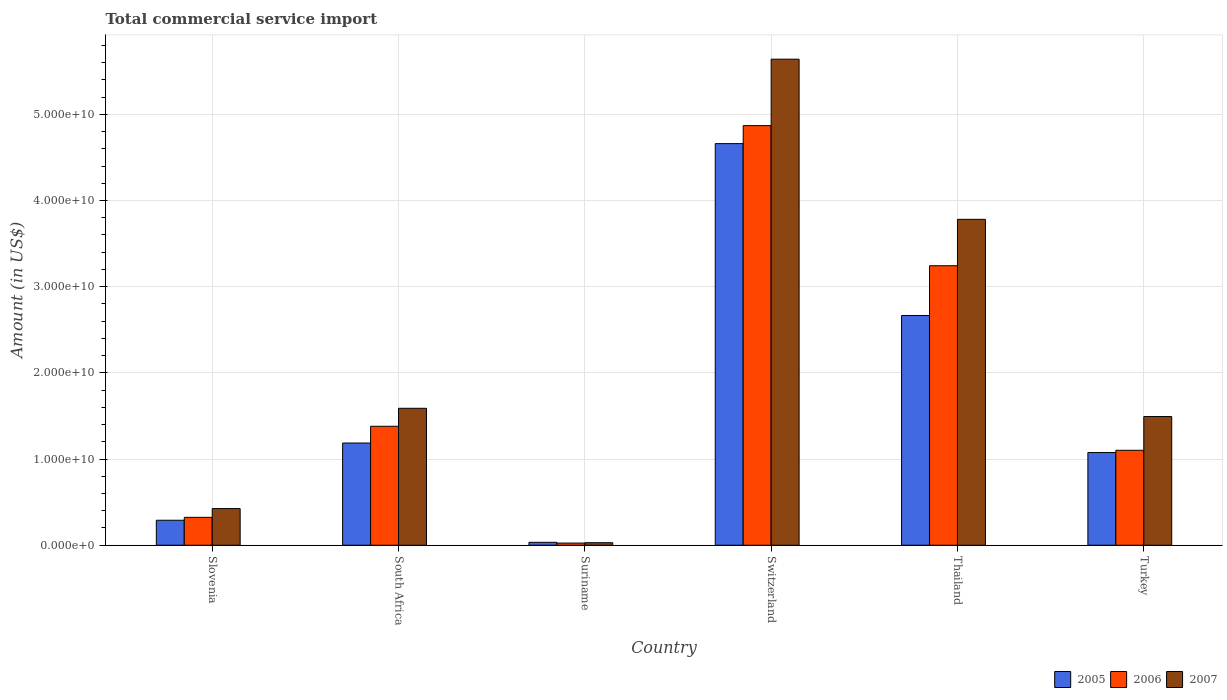How many different coloured bars are there?
Keep it short and to the point. 3. Are the number of bars per tick equal to the number of legend labels?
Ensure brevity in your answer.  Yes. Are the number of bars on each tick of the X-axis equal?
Provide a short and direct response. Yes. What is the total commercial service import in 2005 in Suriname?
Ensure brevity in your answer.  3.39e+08. Across all countries, what is the maximum total commercial service import in 2005?
Give a very brief answer. 4.66e+1. Across all countries, what is the minimum total commercial service import in 2006?
Provide a short and direct response. 2.51e+08. In which country was the total commercial service import in 2005 maximum?
Give a very brief answer. Switzerland. In which country was the total commercial service import in 2006 minimum?
Your response must be concise. Suriname. What is the total total commercial service import in 2005 in the graph?
Offer a terse response. 9.91e+1. What is the difference between the total commercial service import in 2007 in Suriname and that in Turkey?
Offer a terse response. -1.46e+1. What is the difference between the total commercial service import in 2006 in Slovenia and the total commercial service import in 2007 in Suriname?
Ensure brevity in your answer.  2.94e+09. What is the average total commercial service import in 2006 per country?
Keep it short and to the point. 1.82e+1. What is the difference between the total commercial service import of/in 2006 and total commercial service import of/in 2005 in Turkey?
Provide a succinct answer. 2.61e+08. In how many countries, is the total commercial service import in 2006 greater than 6000000000 US$?
Keep it short and to the point. 4. What is the ratio of the total commercial service import in 2005 in Slovenia to that in Switzerland?
Your answer should be very brief. 0.06. Is the total commercial service import in 2007 in Switzerland less than that in Thailand?
Ensure brevity in your answer.  No. What is the difference between the highest and the second highest total commercial service import in 2006?
Offer a very short reply. -1.63e+1. What is the difference between the highest and the lowest total commercial service import in 2005?
Offer a very short reply. 4.63e+1. In how many countries, is the total commercial service import in 2006 greater than the average total commercial service import in 2006 taken over all countries?
Keep it short and to the point. 2. Is the sum of the total commercial service import in 2005 in South Africa and Thailand greater than the maximum total commercial service import in 2006 across all countries?
Your answer should be very brief. No. Is it the case that in every country, the sum of the total commercial service import in 2007 and total commercial service import in 2006 is greater than the total commercial service import in 2005?
Make the answer very short. Yes. What is the difference between two consecutive major ticks on the Y-axis?
Keep it short and to the point. 1.00e+1. Are the values on the major ticks of Y-axis written in scientific E-notation?
Provide a short and direct response. Yes. Does the graph contain any zero values?
Your answer should be compact. No. Does the graph contain grids?
Offer a terse response. Yes. Where does the legend appear in the graph?
Provide a short and direct response. Bottom right. How are the legend labels stacked?
Your answer should be compact. Horizontal. What is the title of the graph?
Give a very brief answer. Total commercial service import. What is the label or title of the X-axis?
Your answer should be compact. Country. What is the Amount (in US$) in 2005 in Slovenia?
Your response must be concise. 2.90e+09. What is the Amount (in US$) of 2006 in Slovenia?
Provide a succinct answer. 3.24e+09. What is the Amount (in US$) in 2007 in Slovenia?
Your response must be concise. 4.25e+09. What is the Amount (in US$) of 2005 in South Africa?
Provide a succinct answer. 1.19e+1. What is the Amount (in US$) in 2006 in South Africa?
Give a very brief answer. 1.38e+1. What is the Amount (in US$) in 2007 in South Africa?
Provide a short and direct response. 1.59e+1. What is the Amount (in US$) in 2005 in Suriname?
Ensure brevity in your answer.  3.39e+08. What is the Amount (in US$) of 2006 in Suriname?
Give a very brief answer. 2.51e+08. What is the Amount (in US$) of 2007 in Suriname?
Keep it short and to the point. 2.93e+08. What is the Amount (in US$) in 2005 in Switzerland?
Give a very brief answer. 4.66e+1. What is the Amount (in US$) in 2006 in Switzerland?
Provide a succinct answer. 4.87e+1. What is the Amount (in US$) in 2007 in Switzerland?
Keep it short and to the point. 5.64e+1. What is the Amount (in US$) of 2005 in Thailand?
Your answer should be very brief. 2.67e+1. What is the Amount (in US$) in 2006 in Thailand?
Your answer should be compact. 3.24e+1. What is the Amount (in US$) in 2007 in Thailand?
Your response must be concise. 3.78e+1. What is the Amount (in US$) in 2005 in Turkey?
Your answer should be compact. 1.08e+1. What is the Amount (in US$) in 2006 in Turkey?
Keep it short and to the point. 1.10e+1. What is the Amount (in US$) in 2007 in Turkey?
Offer a terse response. 1.49e+1. Across all countries, what is the maximum Amount (in US$) of 2005?
Your answer should be very brief. 4.66e+1. Across all countries, what is the maximum Amount (in US$) of 2006?
Keep it short and to the point. 4.87e+1. Across all countries, what is the maximum Amount (in US$) of 2007?
Provide a short and direct response. 5.64e+1. Across all countries, what is the minimum Amount (in US$) in 2005?
Make the answer very short. 3.39e+08. Across all countries, what is the minimum Amount (in US$) in 2006?
Provide a succinct answer. 2.51e+08. Across all countries, what is the minimum Amount (in US$) of 2007?
Your response must be concise. 2.93e+08. What is the total Amount (in US$) in 2005 in the graph?
Your answer should be compact. 9.91e+1. What is the total Amount (in US$) of 2006 in the graph?
Make the answer very short. 1.09e+11. What is the total Amount (in US$) in 2007 in the graph?
Your answer should be very brief. 1.30e+11. What is the difference between the Amount (in US$) in 2005 in Slovenia and that in South Africa?
Offer a terse response. -8.96e+09. What is the difference between the Amount (in US$) in 2006 in Slovenia and that in South Africa?
Keep it short and to the point. -1.06e+1. What is the difference between the Amount (in US$) of 2007 in Slovenia and that in South Africa?
Your answer should be compact. -1.16e+1. What is the difference between the Amount (in US$) in 2005 in Slovenia and that in Suriname?
Ensure brevity in your answer.  2.56e+09. What is the difference between the Amount (in US$) of 2006 in Slovenia and that in Suriname?
Ensure brevity in your answer.  2.98e+09. What is the difference between the Amount (in US$) of 2007 in Slovenia and that in Suriname?
Provide a succinct answer. 3.96e+09. What is the difference between the Amount (in US$) in 2005 in Slovenia and that in Switzerland?
Provide a succinct answer. -4.37e+1. What is the difference between the Amount (in US$) of 2006 in Slovenia and that in Switzerland?
Ensure brevity in your answer.  -4.55e+1. What is the difference between the Amount (in US$) in 2007 in Slovenia and that in Switzerland?
Provide a succinct answer. -5.21e+1. What is the difference between the Amount (in US$) in 2005 in Slovenia and that in Thailand?
Your answer should be compact. -2.38e+1. What is the difference between the Amount (in US$) of 2006 in Slovenia and that in Thailand?
Ensure brevity in your answer.  -2.92e+1. What is the difference between the Amount (in US$) in 2007 in Slovenia and that in Thailand?
Your answer should be very brief. -3.36e+1. What is the difference between the Amount (in US$) of 2005 in Slovenia and that in Turkey?
Your answer should be compact. -7.86e+09. What is the difference between the Amount (in US$) in 2006 in Slovenia and that in Turkey?
Your answer should be compact. -7.78e+09. What is the difference between the Amount (in US$) of 2007 in Slovenia and that in Turkey?
Your answer should be compact. -1.07e+1. What is the difference between the Amount (in US$) of 2005 in South Africa and that in Suriname?
Give a very brief answer. 1.15e+1. What is the difference between the Amount (in US$) in 2006 in South Africa and that in Suriname?
Give a very brief answer. 1.36e+1. What is the difference between the Amount (in US$) in 2007 in South Africa and that in Suriname?
Make the answer very short. 1.56e+1. What is the difference between the Amount (in US$) of 2005 in South Africa and that in Switzerland?
Your answer should be very brief. -3.47e+1. What is the difference between the Amount (in US$) in 2006 in South Africa and that in Switzerland?
Ensure brevity in your answer.  -3.49e+1. What is the difference between the Amount (in US$) of 2007 in South Africa and that in Switzerland?
Offer a terse response. -4.05e+1. What is the difference between the Amount (in US$) in 2005 in South Africa and that in Thailand?
Offer a terse response. -1.48e+1. What is the difference between the Amount (in US$) in 2006 in South Africa and that in Thailand?
Your answer should be very brief. -1.86e+1. What is the difference between the Amount (in US$) in 2007 in South Africa and that in Thailand?
Keep it short and to the point. -2.19e+1. What is the difference between the Amount (in US$) of 2005 in South Africa and that in Turkey?
Ensure brevity in your answer.  1.10e+09. What is the difference between the Amount (in US$) of 2006 in South Africa and that in Turkey?
Provide a succinct answer. 2.79e+09. What is the difference between the Amount (in US$) of 2007 in South Africa and that in Turkey?
Provide a succinct answer. 9.57e+08. What is the difference between the Amount (in US$) in 2005 in Suriname and that in Switzerland?
Provide a succinct answer. -4.63e+1. What is the difference between the Amount (in US$) in 2006 in Suriname and that in Switzerland?
Provide a succinct answer. -4.84e+1. What is the difference between the Amount (in US$) in 2007 in Suriname and that in Switzerland?
Make the answer very short. -5.61e+1. What is the difference between the Amount (in US$) in 2005 in Suriname and that in Thailand?
Provide a succinct answer. -2.63e+1. What is the difference between the Amount (in US$) in 2006 in Suriname and that in Thailand?
Keep it short and to the point. -3.22e+1. What is the difference between the Amount (in US$) of 2007 in Suriname and that in Thailand?
Provide a succinct answer. -3.75e+1. What is the difference between the Amount (in US$) in 2005 in Suriname and that in Turkey?
Your response must be concise. -1.04e+1. What is the difference between the Amount (in US$) of 2006 in Suriname and that in Turkey?
Provide a short and direct response. -1.08e+1. What is the difference between the Amount (in US$) in 2007 in Suriname and that in Turkey?
Ensure brevity in your answer.  -1.46e+1. What is the difference between the Amount (in US$) in 2005 in Switzerland and that in Thailand?
Your answer should be compact. 1.99e+1. What is the difference between the Amount (in US$) of 2006 in Switzerland and that in Thailand?
Offer a very short reply. 1.63e+1. What is the difference between the Amount (in US$) of 2007 in Switzerland and that in Thailand?
Your answer should be very brief. 1.86e+1. What is the difference between the Amount (in US$) of 2005 in Switzerland and that in Turkey?
Ensure brevity in your answer.  3.58e+1. What is the difference between the Amount (in US$) in 2006 in Switzerland and that in Turkey?
Your answer should be very brief. 3.77e+1. What is the difference between the Amount (in US$) in 2007 in Switzerland and that in Turkey?
Offer a very short reply. 4.15e+1. What is the difference between the Amount (in US$) of 2005 in Thailand and that in Turkey?
Provide a short and direct response. 1.59e+1. What is the difference between the Amount (in US$) in 2006 in Thailand and that in Turkey?
Provide a succinct answer. 2.14e+1. What is the difference between the Amount (in US$) in 2007 in Thailand and that in Turkey?
Your response must be concise. 2.29e+1. What is the difference between the Amount (in US$) of 2005 in Slovenia and the Amount (in US$) of 2006 in South Africa?
Your response must be concise. -1.09e+1. What is the difference between the Amount (in US$) in 2005 in Slovenia and the Amount (in US$) in 2007 in South Africa?
Provide a short and direct response. -1.30e+1. What is the difference between the Amount (in US$) of 2006 in Slovenia and the Amount (in US$) of 2007 in South Africa?
Offer a terse response. -1.27e+1. What is the difference between the Amount (in US$) in 2005 in Slovenia and the Amount (in US$) in 2006 in Suriname?
Make the answer very short. 2.65e+09. What is the difference between the Amount (in US$) of 2005 in Slovenia and the Amount (in US$) of 2007 in Suriname?
Your response must be concise. 2.61e+09. What is the difference between the Amount (in US$) of 2006 in Slovenia and the Amount (in US$) of 2007 in Suriname?
Your answer should be very brief. 2.94e+09. What is the difference between the Amount (in US$) in 2005 in Slovenia and the Amount (in US$) in 2006 in Switzerland?
Your answer should be very brief. -4.58e+1. What is the difference between the Amount (in US$) of 2005 in Slovenia and the Amount (in US$) of 2007 in Switzerland?
Offer a very short reply. -5.35e+1. What is the difference between the Amount (in US$) of 2006 in Slovenia and the Amount (in US$) of 2007 in Switzerland?
Keep it short and to the point. -5.32e+1. What is the difference between the Amount (in US$) of 2005 in Slovenia and the Amount (in US$) of 2006 in Thailand?
Offer a terse response. -2.95e+1. What is the difference between the Amount (in US$) in 2005 in Slovenia and the Amount (in US$) in 2007 in Thailand?
Offer a very short reply. -3.49e+1. What is the difference between the Amount (in US$) in 2006 in Slovenia and the Amount (in US$) in 2007 in Thailand?
Provide a succinct answer. -3.46e+1. What is the difference between the Amount (in US$) in 2005 in Slovenia and the Amount (in US$) in 2006 in Turkey?
Provide a succinct answer. -8.12e+09. What is the difference between the Amount (in US$) of 2005 in Slovenia and the Amount (in US$) of 2007 in Turkey?
Your answer should be compact. -1.20e+1. What is the difference between the Amount (in US$) in 2006 in Slovenia and the Amount (in US$) in 2007 in Turkey?
Make the answer very short. -1.17e+1. What is the difference between the Amount (in US$) of 2005 in South Africa and the Amount (in US$) of 2006 in Suriname?
Provide a succinct answer. 1.16e+1. What is the difference between the Amount (in US$) in 2005 in South Africa and the Amount (in US$) in 2007 in Suriname?
Offer a terse response. 1.16e+1. What is the difference between the Amount (in US$) of 2006 in South Africa and the Amount (in US$) of 2007 in Suriname?
Offer a very short reply. 1.35e+1. What is the difference between the Amount (in US$) of 2005 in South Africa and the Amount (in US$) of 2006 in Switzerland?
Give a very brief answer. -3.68e+1. What is the difference between the Amount (in US$) of 2005 in South Africa and the Amount (in US$) of 2007 in Switzerland?
Your response must be concise. -4.45e+1. What is the difference between the Amount (in US$) of 2006 in South Africa and the Amount (in US$) of 2007 in Switzerland?
Offer a very short reply. -4.26e+1. What is the difference between the Amount (in US$) of 2005 in South Africa and the Amount (in US$) of 2006 in Thailand?
Your answer should be compact. -2.06e+1. What is the difference between the Amount (in US$) in 2005 in South Africa and the Amount (in US$) in 2007 in Thailand?
Your answer should be very brief. -2.60e+1. What is the difference between the Amount (in US$) of 2006 in South Africa and the Amount (in US$) of 2007 in Thailand?
Provide a succinct answer. -2.40e+1. What is the difference between the Amount (in US$) of 2005 in South Africa and the Amount (in US$) of 2006 in Turkey?
Make the answer very short. 8.42e+08. What is the difference between the Amount (in US$) of 2005 in South Africa and the Amount (in US$) of 2007 in Turkey?
Provide a short and direct response. -3.07e+09. What is the difference between the Amount (in US$) of 2006 in South Africa and the Amount (in US$) of 2007 in Turkey?
Give a very brief answer. -1.13e+09. What is the difference between the Amount (in US$) of 2005 in Suriname and the Amount (in US$) of 2006 in Switzerland?
Offer a terse response. -4.83e+1. What is the difference between the Amount (in US$) of 2005 in Suriname and the Amount (in US$) of 2007 in Switzerland?
Provide a short and direct response. -5.61e+1. What is the difference between the Amount (in US$) of 2006 in Suriname and the Amount (in US$) of 2007 in Switzerland?
Provide a succinct answer. -5.61e+1. What is the difference between the Amount (in US$) in 2005 in Suriname and the Amount (in US$) in 2006 in Thailand?
Provide a short and direct response. -3.21e+1. What is the difference between the Amount (in US$) of 2005 in Suriname and the Amount (in US$) of 2007 in Thailand?
Your answer should be very brief. -3.75e+1. What is the difference between the Amount (in US$) in 2006 in Suriname and the Amount (in US$) in 2007 in Thailand?
Offer a terse response. -3.76e+1. What is the difference between the Amount (in US$) of 2005 in Suriname and the Amount (in US$) of 2006 in Turkey?
Your answer should be very brief. -1.07e+1. What is the difference between the Amount (in US$) in 2005 in Suriname and the Amount (in US$) in 2007 in Turkey?
Provide a succinct answer. -1.46e+1. What is the difference between the Amount (in US$) of 2006 in Suriname and the Amount (in US$) of 2007 in Turkey?
Make the answer very short. -1.47e+1. What is the difference between the Amount (in US$) of 2005 in Switzerland and the Amount (in US$) of 2006 in Thailand?
Provide a short and direct response. 1.42e+1. What is the difference between the Amount (in US$) in 2005 in Switzerland and the Amount (in US$) in 2007 in Thailand?
Your response must be concise. 8.79e+09. What is the difference between the Amount (in US$) of 2006 in Switzerland and the Amount (in US$) of 2007 in Thailand?
Your answer should be compact. 1.09e+1. What is the difference between the Amount (in US$) of 2005 in Switzerland and the Amount (in US$) of 2006 in Turkey?
Provide a short and direct response. 3.56e+1. What is the difference between the Amount (in US$) of 2005 in Switzerland and the Amount (in US$) of 2007 in Turkey?
Your response must be concise. 3.17e+1. What is the difference between the Amount (in US$) of 2006 in Switzerland and the Amount (in US$) of 2007 in Turkey?
Provide a short and direct response. 3.38e+1. What is the difference between the Amount (in US$) of 2005 in Thailand and the Amount (in US$) of 2006 in Turkey?
Provide a succinct answer. 1.56e+1. What is the difference between the Amount (in US$) of 2005 in Thailand and the Amount (in US$) of 2007 in Turkey?
Keep it short and to the point. 1.17e+1. What is the difference between the Amount (in US$) in 2006 in Thailand and the Amount (in US$) in 2007 in Turkey?
Give a very brief answer. 1.75e+1. What is the average Amount (in US$) of 2005 per country?
Provide a succinct answer. 1.65e+1. What is the average Amount (in US$) in 2006 per country?
Your answer should be very brief. 1.82e+1. What is the average Amount (in US$) in 2007 per country?
Provide a short and direct response. 2.16e+1. What is the difference between the Amount (in US$) of 2005 and Amount (in US$) of 2006 in Slovenia?
Give a very brief answer. -3.36e+08. What is the difference between the Amount (in US$) of 2005 and Amount (in US$) of 2007 in Slovenia?
Make the answer very short. -1.35e+09. What is the difference between the Amount (in US$) of 2006 and Amount (in US$) of 2007 in Slovenia?
Keep it short and to the point. -1.02e+09. What is the difference between the Amount (in US$) in 2005 and Amount (in US$) in 2006 in South Africa?
Ensure brevity in your answer.  -1.94e+09. What is the difference between the Amount (in US$) of 2005 and Amount (in US$) of 2007 in South Africa?
Provide a succinct answer. -4.03e+09. What is the difference between the Amount (in US$) in 2006 and Amount (in US$) in 2007 in South Africa?
Make the answer very short. -2.09e+09. What is the difference between the Amount (in US$) of 2005 and Amount (in US$) of 2006 in Suriname?
Your response must be concise. 8.83e+07. What is the difference between the Amount (in US$) of 2005 and Amount (in US$) of 2007 in Suriname?
Ensure brevity in your answer.  4.63e+07. What is the difference between the Amount (in US$) of 2006 and Amount (in US$) of 2007 in Suriname?
Provide a succinct answer. -4.20e+07. What is the difference between the Amount (in US$) in 2005 and Amount (in US$) in 2006 in Switzerland?
Keep it short and to the point. -2.09e+09. What is the difference between the Amount (in US$) in 2005 and Amount (in US$) in 2007 in Switzerland?
Ensure brevity in your answer.  -9.80e+09. What is the difference between the Amount (in US$) of 2006 and Amount (in US$) of 2007 in Switzerland?
Your response must be concise. -7.71e+09. What is the difference between the Amount (in US$) in 2005 and Amount (in US$) in 2006 in Thailand?
Keep it short and to the point. -5.77e+09. What is the difference between the Amount (in US$) in 2005 and Amount (in US$) in 2007 in Thailand?
Keep it short and to the point. -1.12e+1. What is the difference between the Amount (in US$) in 2006 and Amount (in US$) in 2007 in Thailand?
Your response must be concise. -5.38e+09. What is the difference between the Amount (in US$) of 2005 and Amount (in US$) of 2006 in Turkey?
Your response must be concise. -2.61e+08. What is the difference between the Amount (in US$) of 2005 and Amount (in US$) of 2007 in Turkey?
Give a very brief answer. -4.18e+09. What is the difference between the Amount (in US$) in 2006 and Amount (in US$) in 2007 in Turkey?
Keep it short and to the point. -3.92e+09. What is the ratio of the Amount (in US$) in 2005 in Slovenia to that in South Africa?
Your response must be concise. 0.24. What is the ratio of the Amount (in US$) of 2006 in Slovenia to that in South Africa?
Give a very brief answer. 0.23. What is the ratio of the Amount (in US$) in 2007 in Slovenia to that in South Africa?
Offer a very short reply. 0.27. What is the ratio of the Amount (in US$) of 2005 in Slovenia to that in Suriname?
Offer a very short reply. 8.55. What is the ratio of the Amount (in US$) in 2006 in Slovenia to that in Suriname?
Keep it short and to the point. 12.9. What is the ratio of the Amount (in US$) in 2007 in Slovenia to that in Suriname?
Make the answer very short. 14.52. What is the ratio of the Amount (in US$) of 2005 in Slovenia to that in Switzerland?
Your response must be concise. 0.06. What is the ratio of the Amount (in US$) in 2006 in Slovenia to that in Switzerland?
Ensure brevity in your answer.  0.07. What is the ratio of the Amount (in US$) in 2007 in Slovenia to that in Switzerland?
Your response must be concise. 0.08. What is the ratio of the Amount (in US$) of 2005 in Slovenia to that in Thailand?
Your response must be concise. 0.11. What is the ratio of the Amount (in US$) in 2006 in Slovenia to that in Thailand?
Your response must be concise. 0.1. What is the ratio of the Amount (in US$) in 2007 in Slovenia to that in Thailand?
Offer a very short reply. 0.11. What is the ratio of the Amount (in US$) in 2005 in Slovenia to that in Turkey?
Keep it short and to the point. 0.27. What is the ratio of the Amount (in US$) of 2006 in Slovenia to that in Turkey?
Offer a very short reply. 0.29. What is the ratio of the Amount (in US$) in 2007 in Slovenia to that in Turkey?
Give a very brief answer. 0.28. What is the ratio of the Amount (in US$) of 2005 in South Africa to that in Suriname?
Ensure brevity in your answer.  34.96. What is the ratio of the Amount (in US$) in 2006 in South Africa to that in Suriname?
Give a very brief answer. 55.01. What is the ratio of the Amount (in US$) in 2007 in South Africa to that in Suriname?
Offer a very short reply. 54.25. What is the ratio of the Amount (in US$) of 2005 in South Africa to that in Switzerland?
Offer a very short reply. 0.25. What is the ratio of the Amount (in US$) in 2006 in South Africa to that in Switzerland?
Your answer should be very brief. 0.28. What is the ratio of the Amount (in US$) of 2007 in South Africa to that in Switzerland?
Ensure brevity in your answer.  0.28. What is the ratio of the Amount (in US$) in 2005 in South Africa to that in Thailand?
Your answer should be compact. 0.44. What is the ratio of the Amount (in US$) in 2006 in South Africa to that in Thailand?
Make the answer very short. 0.43. What is the ratio of the Amount (in US$) of 2007 in South Africa to that in Thailand?
Your answer should be compact. 0.42. What is the ratio of the Amount (in US$) in 2005 in South Africa to that in Turkey?
Keep it short and to the point. 1.1. What is the ratio of the Amount (in US$) of 2006 in South Africa to that in Turkey?
Offer a very short reply. 1.25. What is the ratio of the Amount (in US$) in 2007 in South Africa to that in Turkey?
Provide a succinct answer. 1.06. What is the ratio of the Amount (in US$) of 2005 in Suriname to that in Switzerland?
Offer a terse response. 0.01. What is the ratio of the Amount (in US$) of 2006 in Suriname to that in Switzerland?
Provide a short and direct response. 0.01. What is the ratio of the Amount (in US$) of 2007 in Suriname to that in Switzerland?
Offer a terse response. 0.01. What is the ratio of the Amount (in US$) in 2005 in Suriname to that in Thailand?
Your answer should be compact. 0.01. What is the ratio of the Amount (in US$) in 2006 in Suriname to that in Thailand?
Your answer should be compact. 0.01. What is the ratio of the Amount (in US$) in 2007 in Suriname to that in Thailand?
Provide a succinct answer. 0.01. What is the ratio of the Amount (in US$) of 2005 in Suriname to that in Turkey?
Provide a short and direct response. 0.03. What is the ratio of the Amount (in US$) in 2006 in Suriname to that in Turkey?
Provide a succinct answer. 0.02. What is the ratio of the Amount (in US$) of 2007 in Suriname to that in Turkey?
Offer a very short reply. 0.02. What is the ratio of the Amount (in US$) of 2005 in Switzerland to that in Thailand?
Make the answer very short. 1.75. What is the ratio of the Amount (in US$) of 2006 in Switzerland to that in Thailand?
Give a very brief answer. 1.5. What is the ratio of the Amount (in US$) in 2007 in Switzerland to that in Thailand?
Make the answer very short. 1.49. What is the ratio of the Amount (in US$) in 2005 in Switzerland to that in Turkey?
Offer a very short reply. 4.33. What is the ratio of the Amount (in US$) of 2006 in Switzerland to that in Turkey?
Your answer should be compact. 4.42. What is the ratio of the Amount (in US$) in 2007 in Switzerland to that in Turkey?
Provide a short and direct response. 3.78. What is the ratio of the Amount (in US$) in 2005 in Thailand to that in Turkey?
Give a very brief answer. 2.48. What is the ratio of the Amount (in US$) in 2006 in Thailand to that in Turkey?
Your answer should be compact. 2.94. What is the ratio of the Amount (in US$) of 2007 in Thailand to that in Turkey?
Provide a succinct answer. 2.53. What is the difference between the highest and the second highest Amount (in US$) of 2005?
Keep it short and to the point. 1.99e+1. What is the difference between the highest and the second highest Amount (in US$) in 2006?
Your answer should be very brief. 1.63e+1. What is the difference between the highest and the second highest Amount (in US$) in 2007?
Provide a succinct answer. 1.86e+1. What is the difference between the highest and the lowest Amount (in US$) of 2005?
Provide a short and direct response. 4.63e+1. What is the difference between the highest and the lowest Amount (in US$) of 2006?
Offer a terse response. 4.84e+1. What is the difference between the highest and the lowest Amount (in US$) in 2007?
Your answer should be compact. 5.61e+1. 